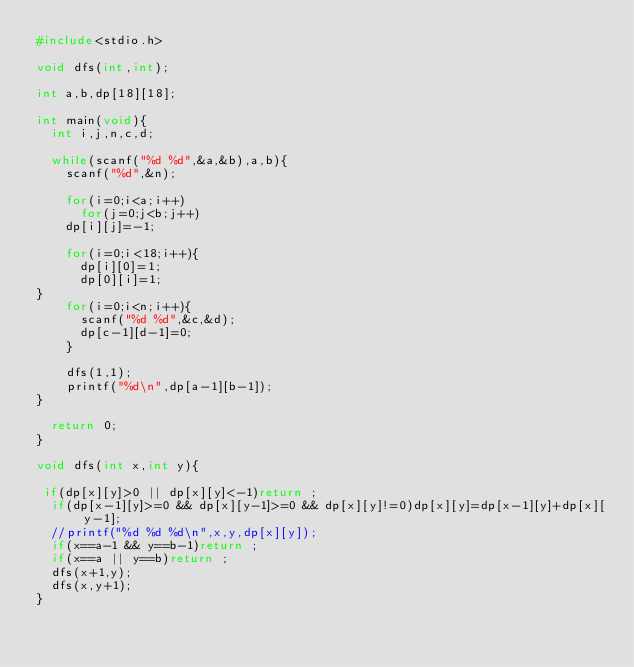Convert code to text. <code><loc_0><loc_0><loc_500><loc_500><_C_>#include<stdio.h>

void dfs(int,int);

int a,b,dp[18][18];

int main(void){
  int i,j,n,c,d;

  while(scanf("%d %d",&a,&b),a,b){
    scanf("%d",&n);

    for(i=0;i<a;i++)
      for(j=0;j<b;j++)
	dp[i][j]=-1;

    for(i=0;i<18;i++){
      dp[i][0]=1;
      dp[0][i]=1;
}
    for(i=0;i<n;i++){
      scanf("%d %d",&c,&d);
      dp[c-1][d-1]=0;
    }

    dfs(1,1);
    printf("%d\n",dp[a-1][b-1]);
}

  return 0;
}

void dfs(int x,int y){

 if(dp[x][y]>0 || dp[x][y]<-1)return ;
  if(dp[x-1][y]>=0 && dp[x][y-1]>=0 && dp[x][y]!=0)dp[x][y]=dp[x-1][y]+dp[x][y-1];
  //printf("%d %d %d\n",x,y,dp[x][y]);
  if(x==a-1 && y==b-1)return ;
  if(x==a || y==b)return ;
  dfs(x+1,y);
  dfs(x,y+1);
}</code> 